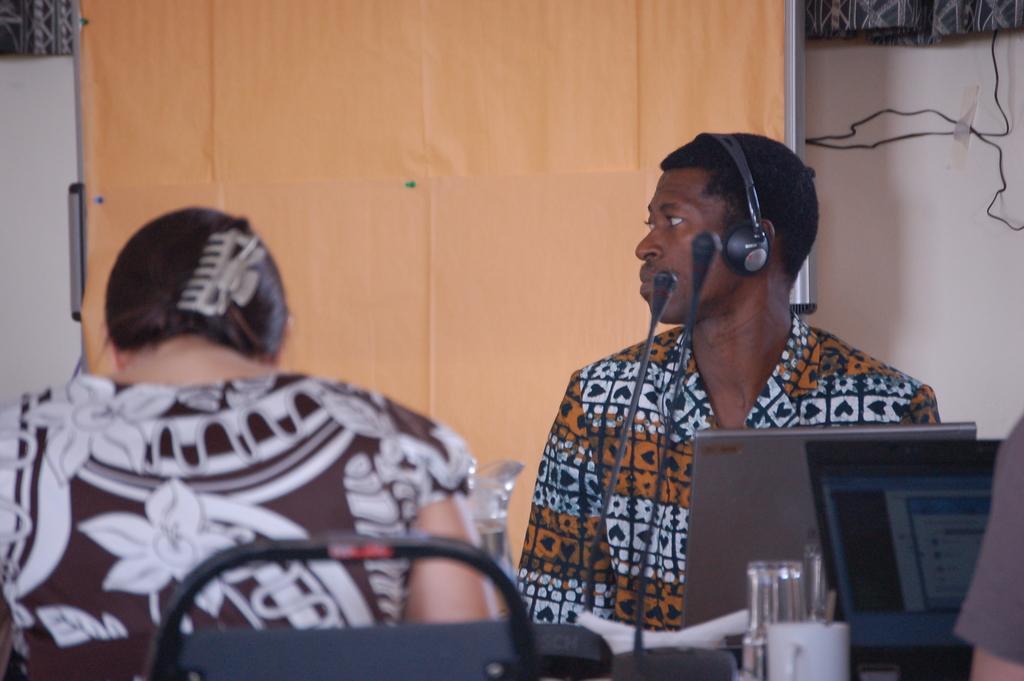In one or two sentences, can you explain what this image depicts? In this image I can see a person wearing different color dress and a headset. Back I can see few mics,system,cup and few objects on the tables. I can see a person is sitting. Back I can see a cream board and white background. 